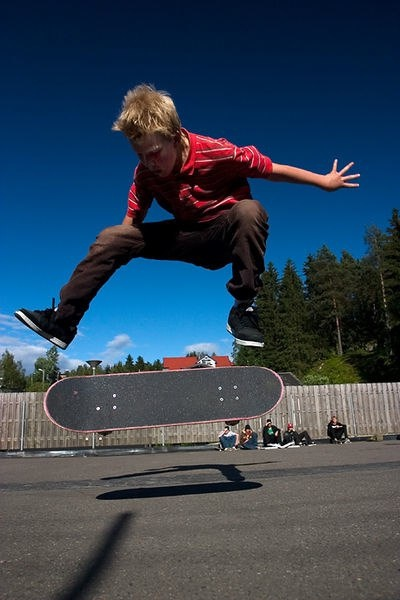Describe the objects in this image and their specific colors. I can see people in black, maroon, navy, and brown tones, skateboard in black and gray tones, people in black, gray, blue, and darkblue tones, people in black, gray, and darkgray tones, and people in black, gray, maroon, and navy tones in this image. 